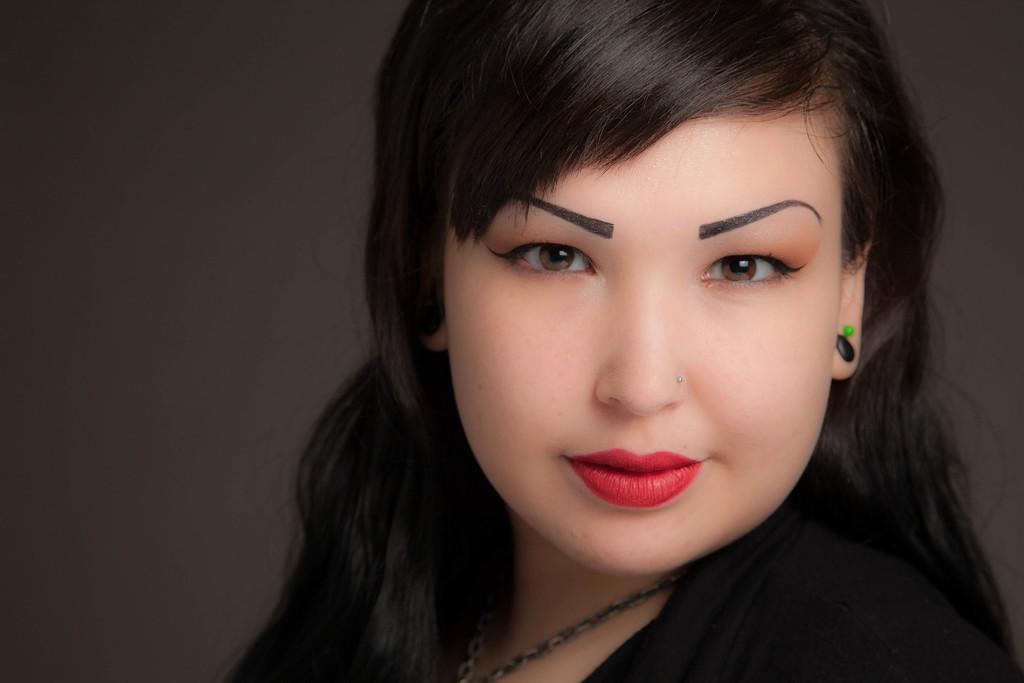Who is the main subject in the image? There is a lady in the center of the image. What can be seen in the background of the image? There is a wall in the background of the image. What type of lace is the lady using to decorate the wall in the image? There is no lace present in the image, and the lady is not decorating the wall. 